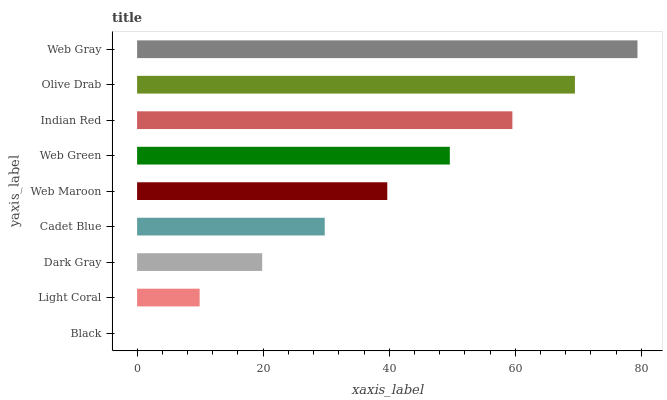Is Black the minimum?
Answer yes or no. Yes. Is Web Gray the maximum?
Answer yes or no. Yes. Is Light Coral the minimum?
Answer yes or no. No. Is Light Coral the maximum?
Answer yes or no. No. Is Light Coral greater than Black?
Answer yes or no. Yes. Is Black less than Light Coral?
Answer yes or no. Yes. Is Black greater than Light Coral?
Answer yes or no. No. Is Light Coral less than Black?
Answer yes or no. No. Is Web Maroon the high median?
Answer yes or no. Yes. Is Web Maroon the low median?
Answer yes or no. Yes. Is Black the high median?
Answer yes or no. No. Is Web Gray the low median?
Answer yes or no. No. 